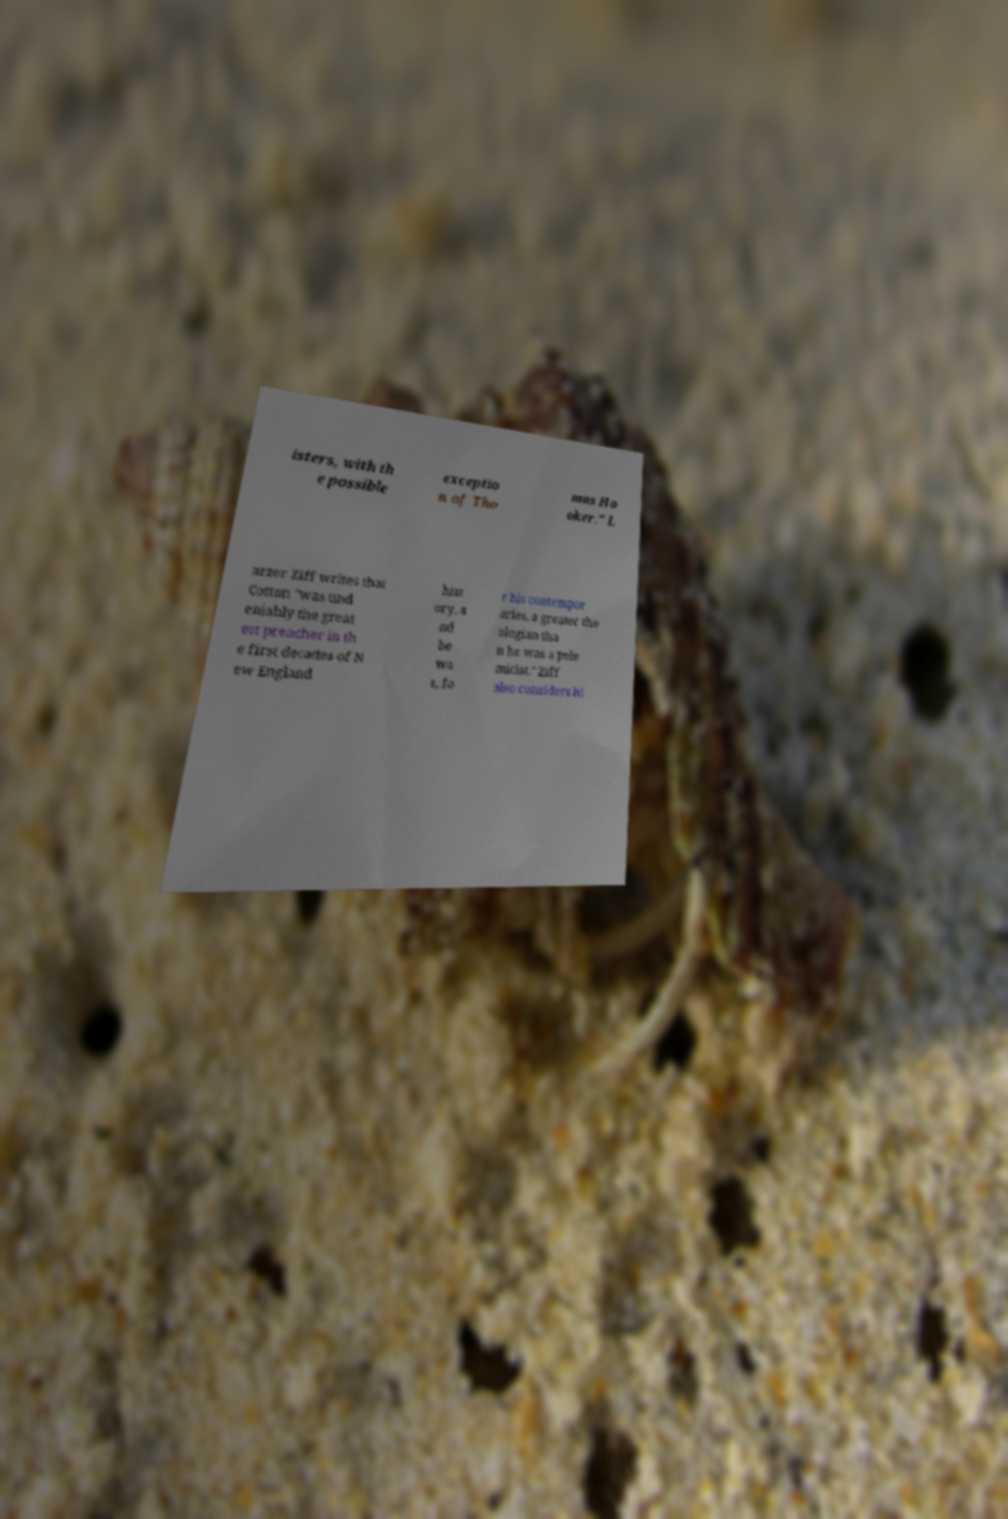What messages or text are displayed in this image? I need them in a readable, typed format. isters, with th e possible exceptio n of Tho mas Ho oker." L arzer Ziff writes that Cotton "was und eniably the great est preacher in th e first decades of N ew England hist ory, a nd he wa s, fo r his contempor aries, a greater the ologian tha n he was a pole micist." Ziff also considers hi 